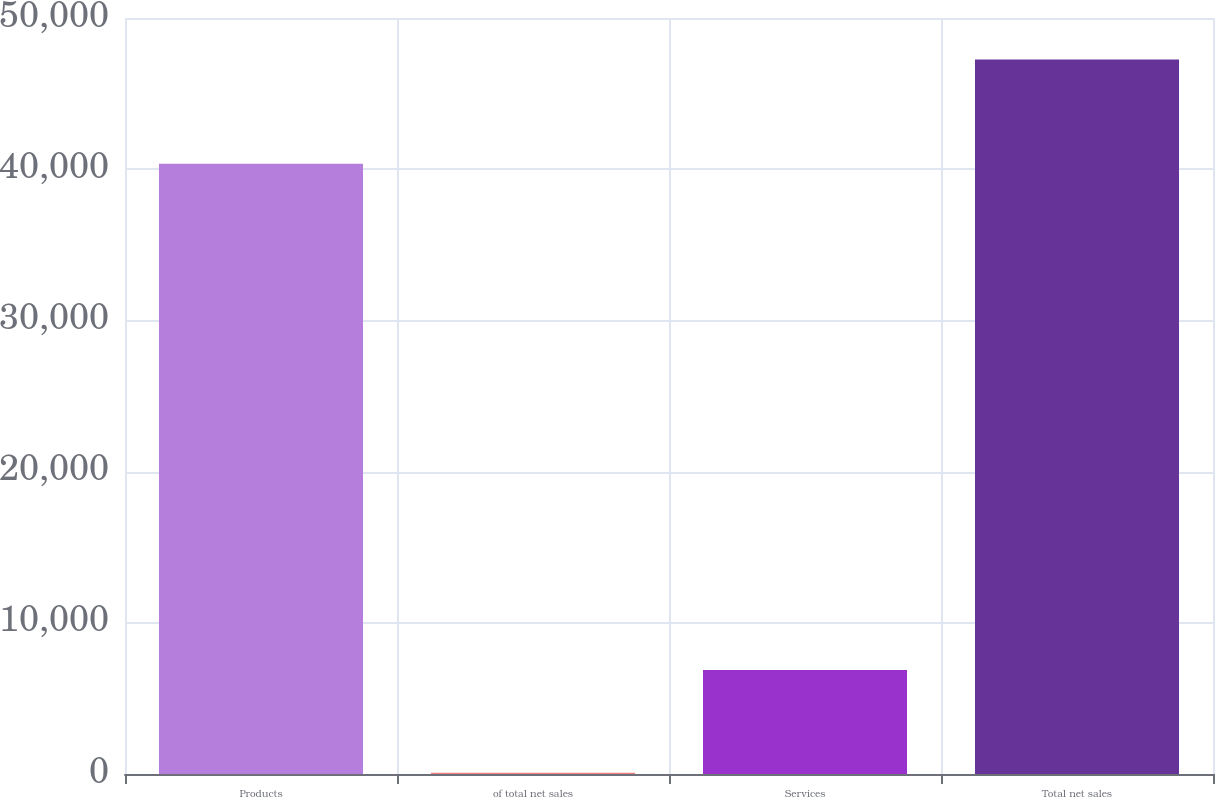Convert chart to OTSL. <chart><loc_0><loc_0><loc_500><loc_500><bar_chart><fcel>Products<fcel>of total net sales<fcel>Services<fcel>Total net sales<nl><fcel>40365<fcel>85.4<fcel>6883<fcel>47248<nl></chart> 